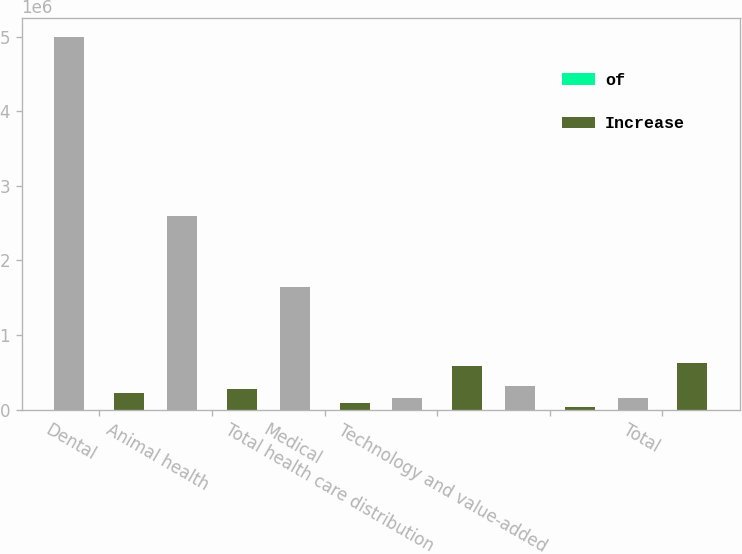Convert chart. <chart><loc_0><loc_0><loc_500><loc_500><stacked_bar_chart><ecel><fcel>Dental<fcel>Animal health<fcel>Medical<fcel>Total health care distribution<fcel>Technology and value-added<fcel>Total<nl><fcel>nan<fcel>4.99797e+06<fcel>2.59946e+06<fcel>1.64317e+06<fcel>152868<fcel>320047<fcel>152868<nl><fcel>of<fcel>52.3<fcel>27.2<fcel>17.2<fcel>96.7<fcel>3.3<fcel>100<nl><fcel>Increase<fcel>223490<fcel>278310<fcel>82246<fcel>584046<fcel>36634<fcel>620680<nl></chart> 